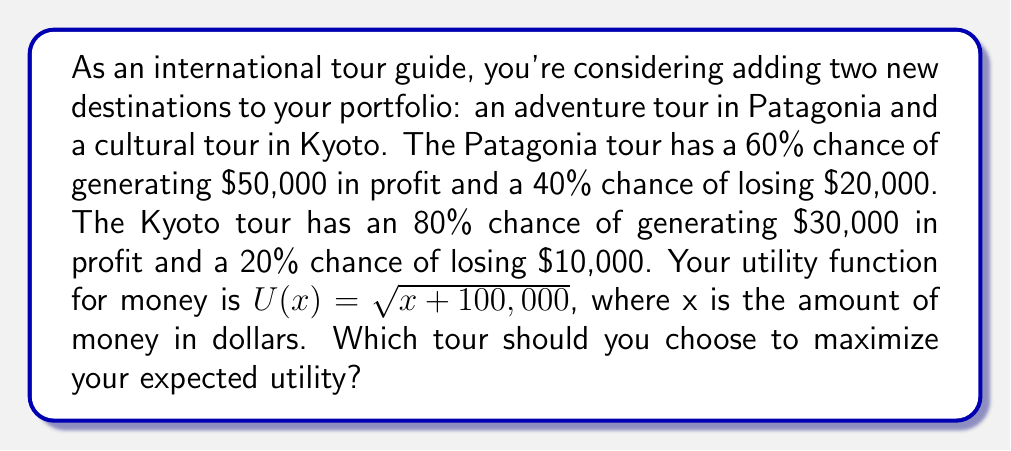Help me with this question. To solve this problem, we need to calculate the expected utility for each tour and compare them. Let's break it down step by step:

1. Calculate the expected utility for the Patagonia tour:

   $E[U(Patagonia)] = 0.6 \times U(50,000) + 0.4 \times U(-20,000)$
   
   $U(50,000) = \sqrt{50,000 + 100,000} = \sqrt{150,000} \approx 387.30$
   $U(-20,000) = \sqrt{-20,000 + 100,000} = \sqrt{80,000} \approx 282.84$
   
   $E[U(Patagonia)] = 0.6 \times 387.30 + 0.4 \times 282.84 = 345.52$

2. Calculate the expected utility for the Kyoto tour:

   $E[U(Kyoto)] = 0.8 \times U(30,000) + 0.2 \times U(-10,000)$
   
   $U(30,000) = \sqrt{30,000 + 100,000} = \sqrt{130,000} \approx 360.56$
   $U(-10,000) = \sqrt{-10,000 + 100,000} = \sqrt{90,000} \approx 300.00$
   
   $E[U(Kyoto)] = 0.8 \times 360.56 + 0.2 \times 300.00 = 348.45$

3. Compare the expected utilities:

   $E[U(Patagonia)] = 345.52$
   $E[U(Kyoto)] = 348.45$

Since the expected utility of the Kyoto tour is higher, it should be chosen to maximize expected utility.
Answer: The Kyoto tour should be chosen, as it has a higher expected utility of 348.45 compared to the Patagonia tour's expected utility of 345.52. 